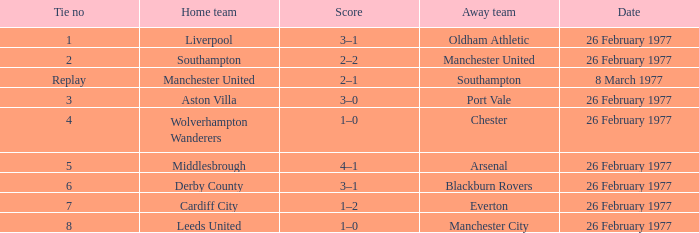Could you parse the entire table? {'header': ['Tie no', 'Home team', 'Score', 'Away team', 'Date'], 'rows': [['1', 'Liverpool', '3–1', 'Oldham Athletic', '26 February 1977'], ['2', 'Southampton', '2–2', 'Manchester United', '26 February 1977'], ['Replay', 'Manchester United', '2–1', 'Southampton', '8 March 1977'], ['3', 'Aston Villa', '3–0', 'Port Vale', '26 February 1977'], ['4', 'Wolverhampton Wanderers', '1–0', 'Chester', '26 February 1977'], ['5', 'Middlesbrough', '4–1', 'Arsenal', '26 February 1977'], ['6', 'Derby County', '3–1', 'Blackburn Rovers', '26 February 1977'], ['7', 'Cardiff City', '1–2', 'Everton', '26 February 1977'], ['8', 'Leeds United', '1–0', 'Manchester City', '26 February 1977']]} What's the score when the deadlock number was 6? 3–1. 